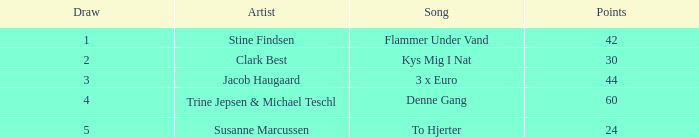Could you parse the entire table? {'header': ['Draw', 'Artist', 'Song', 'Points'], 'rows': [['1', 'Stine Findsen', 'Flammer Under Vand', '42'], ['2', 'Clark Best', 'Kys Mig I Nat', '30'], ['3', 'Jacob Haugaard', '3 x Euro', '44'], ['4', 'Trine Jepsen & Michael Teschl', 'Denne Gang', '60'], ['5', 'Susanne Marcussen', 'To Hjerter', '24']]} What is the lowest Draw when the Artist is Stine Findsen and the Points are larger than 42? None. 